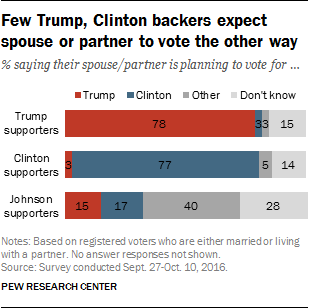Point out several critical features in this image. Please provide the value of the longest red bar, which is 78. In the chart, red represents the data of Donald Trump. 